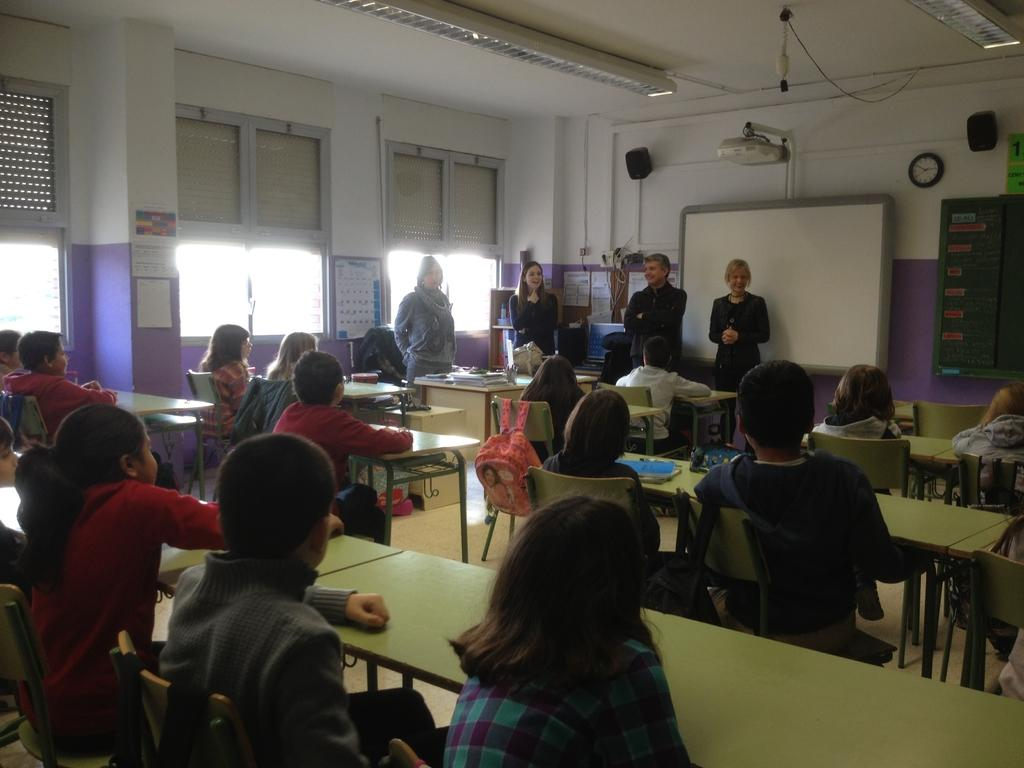What is the main subject of the image? The main subject of the image is a group of children. How are the children positioned in the image? The children are sitting on a chair in the image. What is in front of the children? There is a bench in front of the children. What can be seen in the background of the image? There are four persons standing, a board, a window, and a wall in the background. Can you tell me where the secretary is located in the image? There is no secretary present in the image. Is there any quicksand visible in the image? There is no quicksand present in the image. 